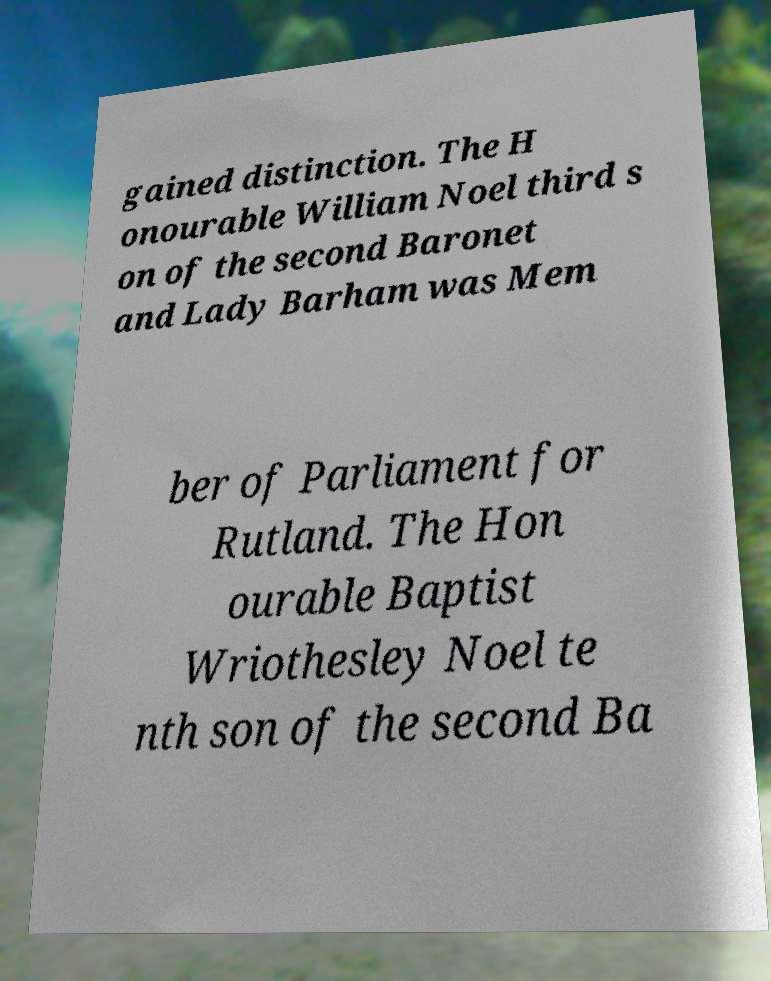What messages or text are displayed in this image? I need them in a readable, typed format. gained distinction. The H onourable William Noel third s on of the second Baronet and Lady Barham was Mem ber of Parliament for Rutland. The Hon ourable Baptist Wriothesley Noel te nth son of the second Ba 